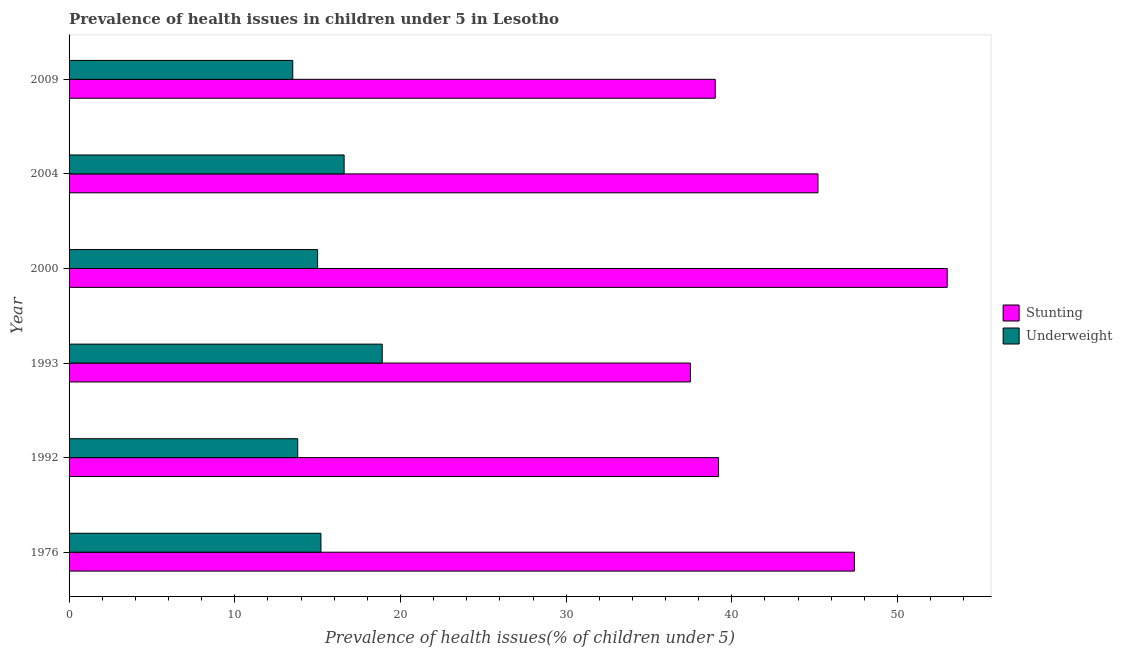Are the number of bars per tick equal to the number of legend labels?
Provide a short and direct response. Yes. Are the number of bars on each tick of the Y-axis equal?
Offer a terse response. Yes. How many bars are there on the 3rd tick from the bottom?
Offer a very short reply. 2. What is the label of the 5th group of bars from the top?
Offer a terse response. 1992. In how many cases, is the number of bars for a given year not equal to the number of legend labels?
Offer a very short reply. 0. What is the percentage of underweight children in 1993?
Give a very brief answer. 18.9. Across all years, what is the maximum percentage of underweight children?
Provide a succinct answer. 18.9. Across all years, what is the minimum percentage of stunted children?
Offer a terse response. 37.5. In which year was the percentage of underweight children minimum?
Provide a short and direct response. 2009. What is the total percentage of underweight children in the graph?
Offer a terse response. 93. What is the difference between the percentage of stunted children in 1976 and that in 2009?
Ensure brevity in your answer.  8.4. What is the difference between the percentage of stunted children in 2009 and the percentage of underweight children in 1992?
Keep it short and to the point. 25.2. What is the average percentage of stunted children per year?
Your answer should be compact. 43.55. In the year 1992, what is the difference between the percentage of underweight children and percentage of stunted children?
Make the answer very short. -25.4. What is the ratio of the percentage of stunted children in 2000 to that in 2009?
Provide a short and direct response. 1.36. Is the percentage of stunted children in 2000 less than that in 2004?
Your answer should be compact. No. What does the 2nd bar from the top in 1993 represents?
Give a very brief answer. Stunting. What does the 1st bar from the bottom in 2004 represents?
Offer a very short reply. Stunting. How many bars are there?
Provide a short and direct response. 12. What is the difference between two consecutive major ticks on the X-axis?
Provide a succinct answer. 10. Does the graph contain any zero values?
Provide a short and direct response. No. What is the title of the graph?
Offer a terse response. Prevalence of health issues in children under 5 in Lesotho. What is the label or title of the X-axis?
Offer a very short reply. Prevalence of health issues(% of children under 5). What is the Prevalence of health issues(% of children under 5) of Stunting in 1976?
Your answer should be very brief. 47.4. What is the Prevalence of health issues(% of children under 5) in Underweight in 1976?
Keep it short and to the point. 15.2. What is the Prevalence of health issues(% of children under 5) in Stunting in 1992?
Your answer should be compact. 39.2. What is the Prevalence of health issues(% of children under 5) in Underweight in 1992?
Offer a very short reply. 13.8. What is the Prevalence of health issues(% of children under 5) of Stunting in 1993?
Your response must be concise. 37.5. What is the Prevalence of health issues(% of children under 5) of Underweight in 1993?
Your answer should be compact. 18.9. What is the Prevalence of health issues(% of children under 5) in Stunting in 2000?
Give a very brief answer. 53. What is the Prevalence of health issues(% of children under 5) of Stunting in 2004?
Provide a short and direct response. 45.2. What is the Prevalence of health issues(% of children under 5) of Underweight in 2004?
Ensure brevity in your answer.  16.6. What is the Prevalence of health issues(% of children under 5) of Underweight in 2009?
Provide a short and direct response. 13.5. Across all years, what is the maximum Prevalence of health issues(% of children under 5) of Stunting?
Offer a terse response. 53. Across all years, what is the maximum Prevalence of health issues(% of children under 5) of Underweight?
Offer a very short reply. 18.9. Across all years, what is the minimum Prevalence of health issues(% of children under 5) in Stunting?
Provide a succinct answer. 37.5. Across all years, what is the minimum Prevalence of health issues(% of children under 5) of Underweight?
Your response must be concise. 13.5. What is the total Prevalence of health issues(% of children under 5) of Stunting in the graph?
Your answer should be very brief. 261.3. What is the total Prevalence of health issues(% of children under 5) of Underweight in the graph?
Your answer should be very brief. 93. What is the difference between the Prevalence of health issues(% of children under 5) in Stunting in 1976 and that in 1992?
Give a very brief answer. 8.2. What is the difference between the Prevalence of health issues(% of children under 5) of Underweight in 1976 and that in 1992?
Offer a very short reply. 1.4. What is the difference between the Prevalence of health issues(% of children under 5) in Underweight in 1976 and that in 1993?
Offer a very short reply. -3.7. What is the difference between the Prevalence of health issues(% of children under 5) of Underweight in 1976 and that in 2004?
Your response must be concise. -1.4. What is the difference between the Prevalence of health issues(% of children under 5) of Underweight in 1976 and that in 2009?
Keep it short and to the point. 1.7. What is the difference between the Prevalence of health issues(% of children under 5) of Stunting in 1992 and that in 1993?
Keep it short and to the point. 1.7. What is the difference between the Prevalence of health issues(% of children under 5) in Underweight in 1992 and that in 1993?
Offer a very short reply. -5.1. What is the difference between the Prevalence of health issues(% of children under 5) in Underweight in 1992 and that in 2000?
Give a very brief answer. -1.2. What is the difference between the Prevalence of health issues(% of children under 5) in Underweight in 1992 and that in 2004?
Offer a terse response. -2.8. What is the difference between the Prevalence of health issues(% of children under 5) of Stunting in 1993 and that in 2000?
Offer a very short reply. -15.5. What is the difference between the Prevalence of health issues(% of children under 5) of Stunting in 1993 and that in 2009?
Your answer should be compact. -1.5. What is the difference between the Prevalence of health issues(% of children under 5) in Stunting in 2000 and that in 2004?
Offer a very short reply. 7.8. What is the difference between the Prevalence of health issues(% of children under 5) in Underweight in 2000 and that in 2009?
Make the answer very short. 1.5. What is the difference between the Prevalence of health issues(% of children under 5) of Stunting in 2004 and that in 2009?
Your answer should be very brief. 6.2. What is the difference between the Prevalence of health issues(% of children under 5) in Stunting in 1976 and the Prevalence of health issues(% of children under 5) in Underweight in 1992?
Your answer should be very brief. 33.6. What is the difference between the Prevalence of health issues(% of children under 5) of Stunting in 1976 and the Prevalence of health issues(% of children under 5) of Underweight in 1993?
Offer a terse response. 28.5. What is the difference between the Prevalence of health issues(% of children under 5) of Stunting in 1976 and the Prevalence of health issues(% of children under 5) of Underweight in 2000?
Provide a short and direct response. 32.4. What is the difference between the Prevalence of health issues(% of children under 5) of Stunting in 1976 and the Prevalence of health issues(% of children under 5) of Underweight in 2004?
Ensure brevity in your answer.  30.8. What is the difference between the Prevalence of health issues(% of children under 5) in Stunting in 1976 and the Prevalence of health issues(% of children under 5) in Underweight in 2009?
Your response must be concise. 33.9. What is the difference between the Prevalence of health issues(% of children under 5) in Stunting in 1992 and the Prevalence of health issues(% of children under 5) in Underweight in 1993?
Give a very brief answer. 20.3. What is the difference between the Prevalence of health issues(% of children under 5) in Stunting in 1992 and the Prevalence of health issues(% of children under 5) in Underweight in 2000?
Ensure brevity in your answer.  24.2. What is the difference between the Prevalence of health issues(% of children under 5) of Stunting in 1992 and the Prevalence of health issues(% of children under 5) of Underweight in 2004?
Offer a terse response. 22.6. What is the difference between the Prevalence of health issues(% of children under 5) in Stunting in 1992 and the Prevalence of health issues(% of children under 5) in Underweight in 2009?
Offer a very short reply. 25.7. What is the difference between the Prevalence of health issues(% of children under 5) of Stunting in 1993 and the Prevalence of health issues(% of children under 5) of Underweight in 2000?
Provide a short and direct response. 22.5. What is the difference between the Prevalence of health issues(% of children under 5) in Stunting in 1993 and the Prevalence of health issues(% of children under 5) in Underweight in 2004?
Offer a very short reply. 20.9. What is the difference between the Prevalence of health issues(% of children under 5) of Stunting in 2000 and the Prevalence of health issues(% of children under 5) of Underweight in 2004?
Offer a very short reply. 36.4. What is the difference between the Prevalence of health issues(% of children under 5) of Stunting in 2000 and the Prevalence of health issues(% of children under 5) of Underweight in 2009?
Make the answer very short. 39.5. What is the difference between the Prevalence of health issues(% of children under 5) of Stunting in 2004 and the Prevalence of health issues(% of children under 5) of Underweight in 2009?
Ensure brevity in your answer.  31.7. What is the average Prevalence of health issues(% of children under 5) of Stunting per year?
Your response must be concise. 43.55. What is the average Prevalence of health issues(% of children under 5) of Underweight per year?
Offer a very short reply. 15.5. In the year 1976, what is the difference between the Prevalence of health issues(% of children under 5) of Stunting and Prevalence of health issues(% of children under 5) of Underweight?
Ensure brevity in your answer.  32.2. In the year 1992, what is the difference between the Prevalence of health issues(% of children under 5) in Stunting and Prevalence of health issues(% of children under 5) in Underweight?
Offer a terse response. 25.4. In the year 1993, what is the difference between the Prevalence of health issues(% of children under 5) of Stunting and Prevalence of health issues(% of children under 5) of Underweight?
Your answer should be very brief. 18.6. In the year 2004, what is the difference between the Prevalence of health issues(% of children under 5) in Stunting and Prevalence of health issues(% of children under 5) in Underweight?
Provide a short and direct response. 28.6. In the year 2009, what is the difference between the Prevalence of health issues(% of children under 5) in Stunting and Prevalence of health issues(% of children under 5) in Underweight?
Your response must be concise. 25.5. What is the ratio of the Prevalence of health issues(% of children under 5) of Stunting in 1976 to that in 1992?
Your response must be concise. 1.21. What is the ratio of the Prevalence of health issues(% of children under 5) of Underweight in 1976 to that in 1992?
Make the answer very short. 1.1. What is the ratio of the Prevalence of health issues(% of children under 5) in Stunting in 1976 to that in 1993?
Ensure brevity in your answer.  1.26. What is the ratio of the Prevalence of health issues(% of children under 5) in Underweight in 1976 to that in 1993?
Provide a short and direct response. 0.8. What is the ratio of the Prevalence of health issues(% of children under 5) of Stunting in 1976 to that in 2000?
Offer a terse response. 0.89. What is the ratio of the Prevalence of health issues(% of children under 5) of Underweight in 1976 to that in 2000?
Your answer should be very brief. 1.01. What is the ratio of the Prevalence of health issues(% of children under 5) in Stunting in 1976 to that in 2004?
Your answer should be very brief. 1.05. What is the ratio of the Prevalence of health issues(% of children under 5) of Underweight in 1976 to that in 2004?
Give a very brief answer. 0.92. What is the ratio of the Prevalence of health issues(% of children under 5) in Stunting in 1976 to that in 2009?
Offer a very short reply. 1.22. What is the ratio of the Prevalence of health issues(% of children under 5) of Underweight in 1976 to that in 2009?
Your answer should be very brief. 1.13. What is the ratio of the Prevalence of health issues(% of children under 5) in Stunting in 1992 to that in 1993?
Offer a terse response. 1.05. What is the ratio of the Prevalence of health issues(% of children under 5) of Underweight in 1992 to that in 1993?
Your response must be concise. 0.73. What is the ratio of the Prevalence of health issues(% of children under 5) in Stunting in 1992 to that in 2000?
Offer a terse response. 0.74. What is the ratio of the Prevalence of health issues(% of children under 5) of Underweight in 1992 to that in 2000?
Keep it short and to the point. 0.92. What is the ratio of the Prevalence of health issues(% of children under 5) in Stunting in 1992 to that in 2004?
Your answer should be compact. 0.87. What is the ratio of the Prevalence of health issues(% of children under 5) in Underweight in 1992 to that in 2004?
Provide a succinct answer. 0.83. What is the ratio of the Prevalence of health issues(% of children under 5) in Stunting in 1992 to that in 2009?
Provide a short and direct response. 1.01. What is the ratio of the Prevalence of health issues(% of children under 5) in Underweight in 1992 to that in 2009?
Make the answer very short. 1.02. What is the ratio of the Prevalence of health issues(% of children under 5) in Stunting in 1993 to that in 2000?
Keep it short and to the point. 0.71. What is the ratio of the Prevalence of health issues(% of children under 5) in Underweight in 1993 to that in 2000?
Your answer should be very brief. 1.26. What is the ratio of the Prevalence of health issues(% of children under 5) in Stunting in 1993 to that in 2004?
Offer a very short reply. 0.83. What is the ratio of the Prevalence of health issues(% of children under 5) in Underweight in 1993 to that in 2004?
Offer a terse response. 1.14. What is the ratio of the Prevalence of health issues(% of children under 5) of Stunting in 1993 to that in 2009?
Make the answer very short. 0.96. What is the ratio of the Prevalence of health issues(% of children under 5) of Underweight in 1993 to that in 2009?
Provide a succinct answer. 1.4. What is the ratio of the Prevalence of health issues(% of children under 5) in Stunting in 2000 to that in 2004?
Your response must be concise. 1.17. What is the ratio of the Prevalence of health issues(% of children under 5) of Underweight in 2000 to that in 2004?
Your answer should be compact. 0.9. What is the ratio of the Prevalence of health issues(% of children under 5) of Stunting in 2000 to that in 2009?
Offer a very short reply. 1.36. What is the ratio of the Prevalence of health issues(% of children under 5) in Underweight in 2000 to that in 2009?
Your answer should be very brief. 1.11. What is the ratio of the Prevalence of health issues(% of children under 5) in Stunting in 2004 to that in 2009?
Offer a very short reply. 1.16. What is the ratio of the Prevalence of health issues(% of children under 5) in Underweight in 2004 to that in 2009?
Keep it short and to the point. 1.23. What is the difference between the highest and the second highest Prevalence of health issues(% of children under 5) in Stunting?
Ensure brevity in your answer.  5.6. 